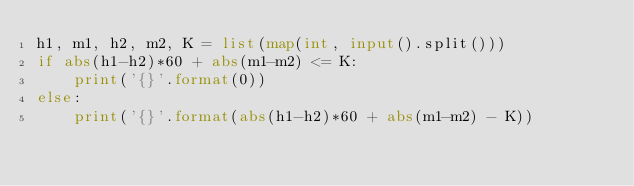Convert code to text. <code><loc_0><loc_0><loc_500><loc_500><_Python_>h1, m1, h2, m2, K = list(map(int, input().split()))
if abs(h1-h2)*60 + abs(m1-m2) <= K:
    print('{}'.format(0))
else:
    print('{}'.format(abs(h1-h2)*60 + abs(m1-m2) - K))</code> 